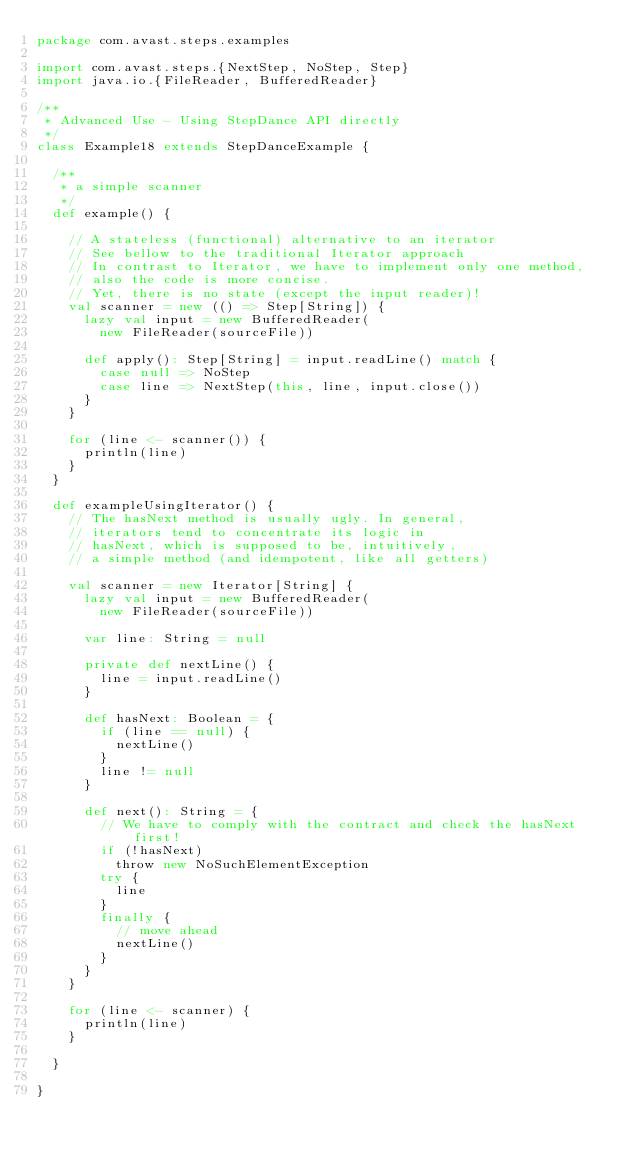<code> <loc_0><loc_0><loc_500><loc_500><_Scala_>package com.avast.steps.examples

import com.avast.steps.{NextStep, NoStep, Step}
import java.io.{FileReader, BufferedReader}

/**
 * Advanced Use - Using StepDance API directly
 */
class Example18 extends StepDanceExample {

  /**
   * a simple scanner
   */
  def example() {

    // A stateless (functional) alternative to an iterator
    // See bellow to the traditional Iterator approach
    // In contrast to Iterator, we have to implement only one method,
    // also the code is more concise.
    // Yet, there is no state (except the input reader)!
    val scanner = new (() => Step[String]) {
      lazy val input = new BufferedReader(
        new FileReader(sourceFile))

      def apply(): Step[String] = input.readLine() match {
        case null => NoStep
        case line => NextStep(this, line, input.close())
      }
    }

    for (line <- scanner()) {
      println(line)
    }
  }

  def exampleUsingIterator() {
    // The hasNext method is usually ugly. In general,
    // iterators tend to concentrate its logic in
    // hasNext, which is supposed to be, intuitively,
    // a simple method (and idempotent, like all getters)

    val scanner = new Iterator[String] {
      lazy val input = new BufferedReader(
        new FileReader(sourceFile))

      var line: String = null

      private def nextLine() {
        line = input.readLine()
      }

      def hasNext: Boolean = {
        if (line == null) {
          nextLine()
        }
        line != null
      }

      def next(): String = {
        // We have to comply with the contract and check the hasNext first!
        if (!hasNext)
          throw new NoSuchElementException
        try {
          line
        }
        finally {
          // move ahead
          nextLine()
        }
      }
    }

    for (line <- scanner) {
      println(line)
    }

  }

}
</code> 